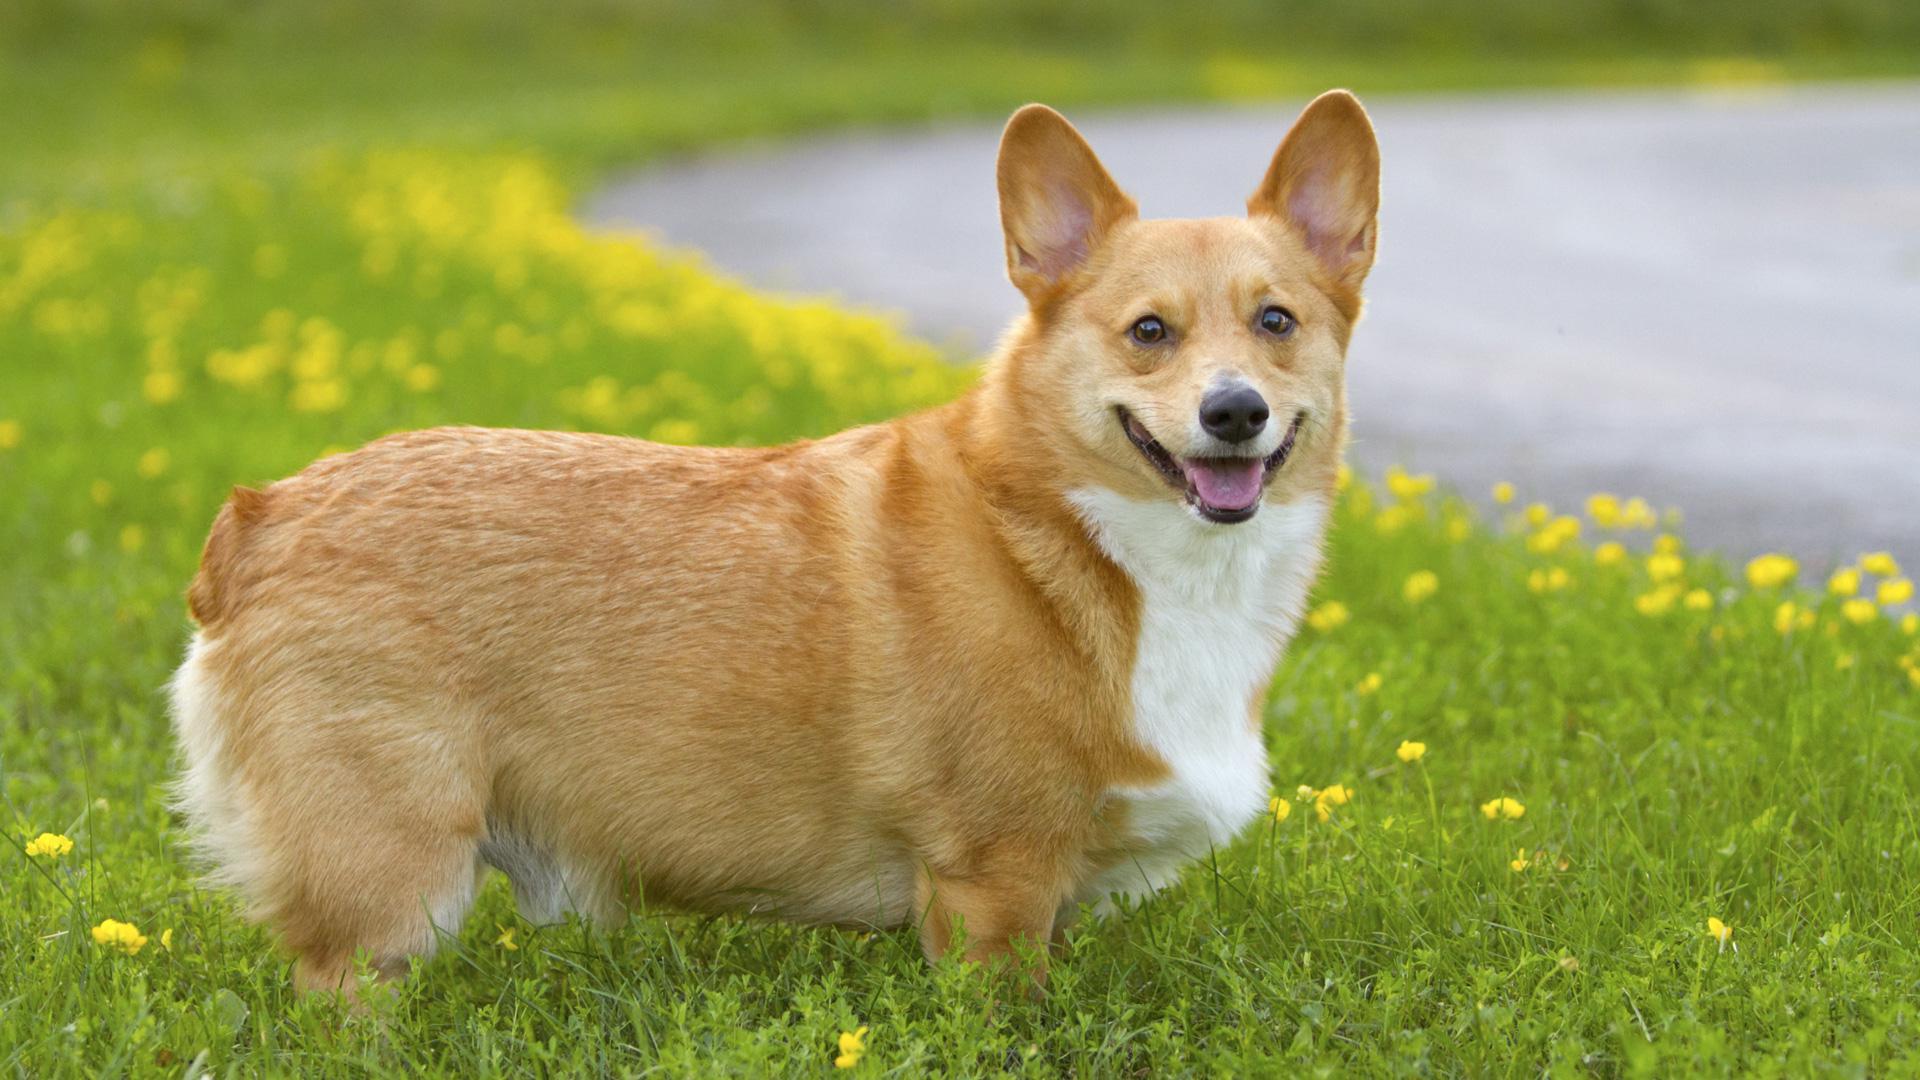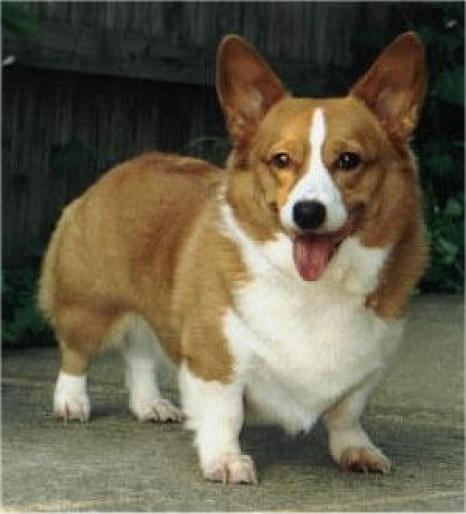The first image is the image on the left, the second image is the image on the right. For the images displayed, is the sentence "One dog has his mouth shut." factually correct? Answer yes or no. No. The first image is the image on the left, the second image is the image on the right. Evaluate the accuracy of this statement regarding the images: "The dogs are all either standing or sitting while looking at the camera.". Is it true? Answer yes or no. Yes. 